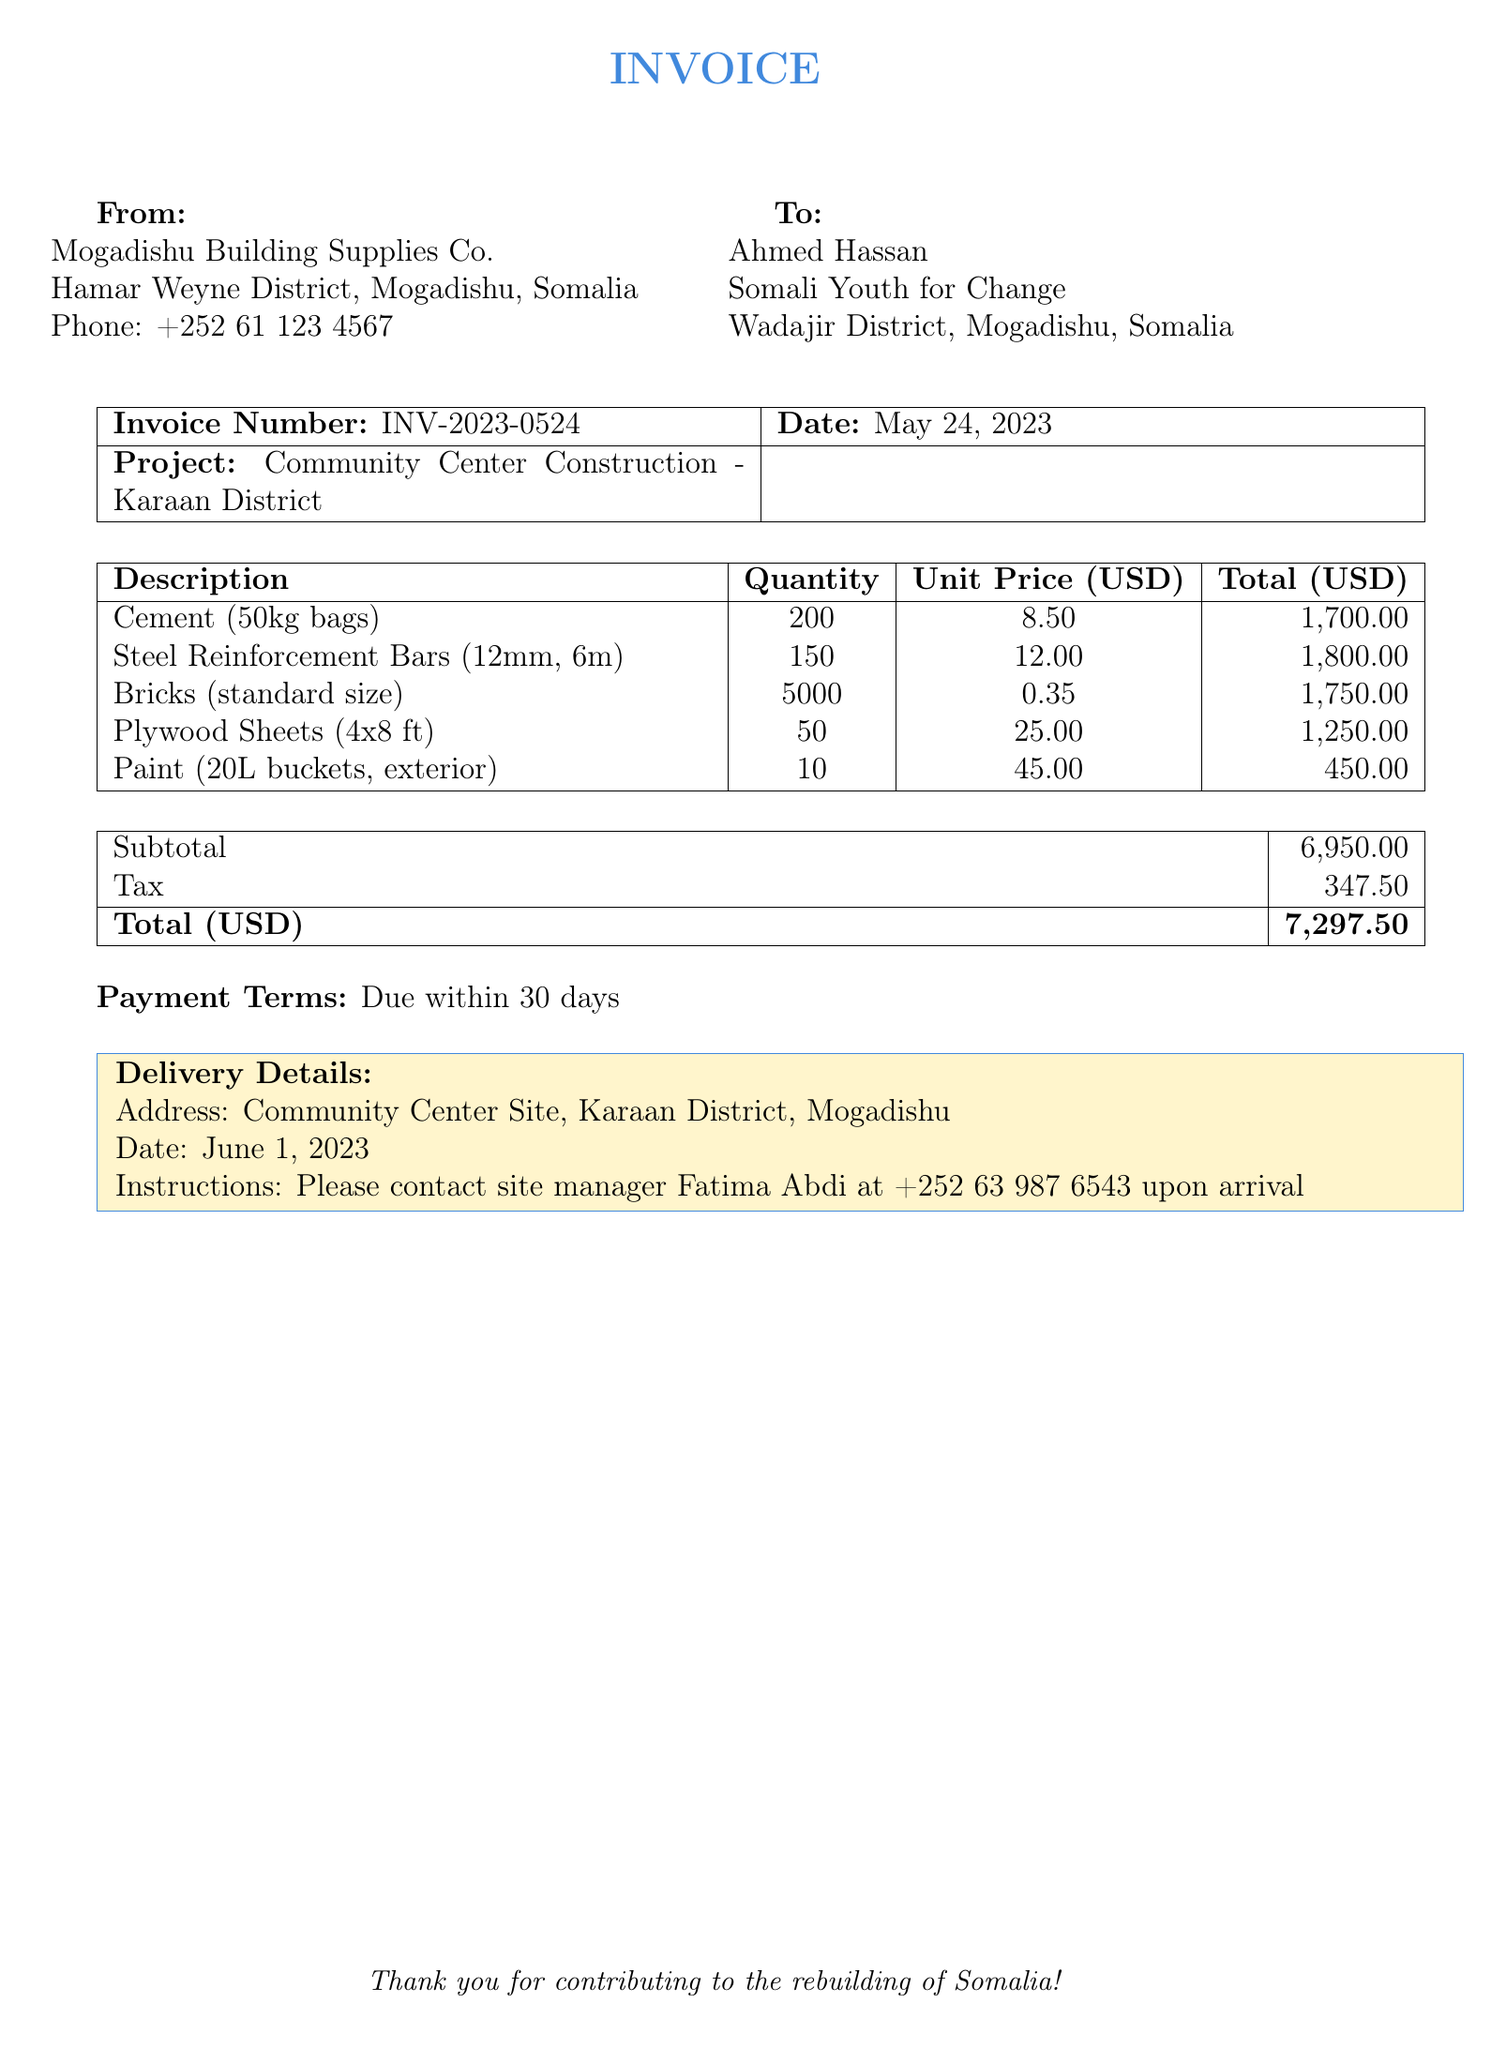What is the invoice number? The invoice number is a unique identifier for the billing document provided, listed as INV-2023-0524.
Answer: INV-2023-0524 What is the total amount due? The total amount due is the final sum of payment obligated in the invoice, which includes subtotal and tax.
Answer: 7,297.50 How many bags of cement were purchased? The document specifies the quantity of cement bags acquired, which is clearly listed as 200.
Answer: 200 Who is the contact person at the delivery site? The invoice includes a name and contact information for delivery instructions, which is Fatima Abdi.
Answer: Fatima Abdi What date is the payment due? The invoice outlines the payment terms, stating that payment is required within a specific number of days, indicating a due date in relation to the invoice date.
Answer: 30 days What is the tax amount charged? The tax charged in the document is mentioned as a specific amount, which is relevant for financial records.
Answer: 347.50 What is the subtotal before tax? The subtotal is the sum of all itemized costs before tax is applied, a crucial figure in financial documents.
Answer: 6,950.00 How many plywood sheets were ordered? The document specifies the quantity of plywood purchased, providing clarity on this particular material expense.
Answer: 50 What is the delivery date? The invoice includes delivery details, such as the date when the materials are expected to arrive.
Answer: June 1, 2023 